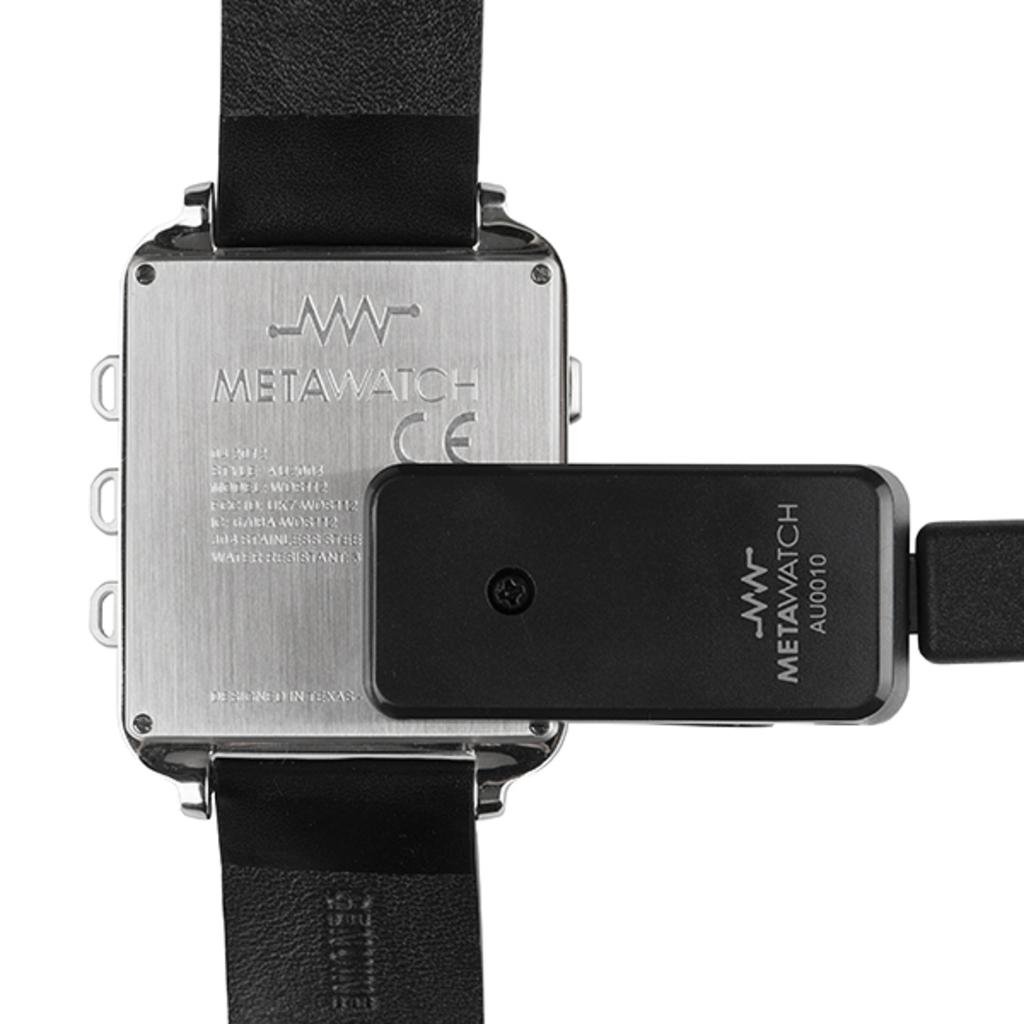<image>
Relay a brief, clear account of the picture shown. the back of a Meta Watch with a black leather band 